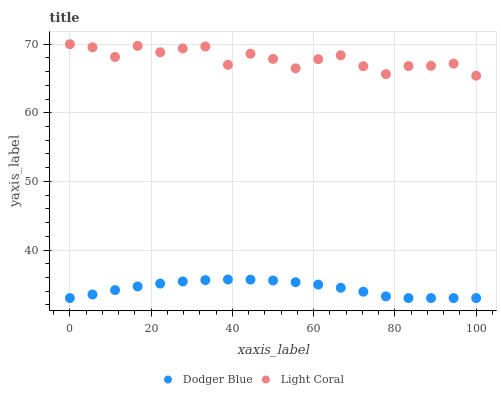Does Dodger Blue have the minimum area under the curve?
Answer yes or no. Yes. Does Light Coral have the maximum area under the curve?
Answer yes or no. Yes. Does Dodger Blue have the maximum area under the curve?
Answer yes or no. No. Is Dodger Blue the smoothest?
Answer yes or no. Yes. Is Light Coral the roughest?
Answer yes or no. Yes. Is Dodger Blue the roughest?
Answer yes or no. No. Does Dodger Blue have the lowest value?
Answer yes or no. Yes. Does Light Coral have the highest value?
Answer yes or no. Yes. Does Dodger Blue have the highest value?
Answer yes or no. No. Is Dodger Blue less than Light Coral?
Answer yes or no. Yes. Is Light Coral greater than Dodger Blue?
Answer yes or no. Yes. Does Dodger Blue intersect Light Coral?
Answer yes or no. No. 